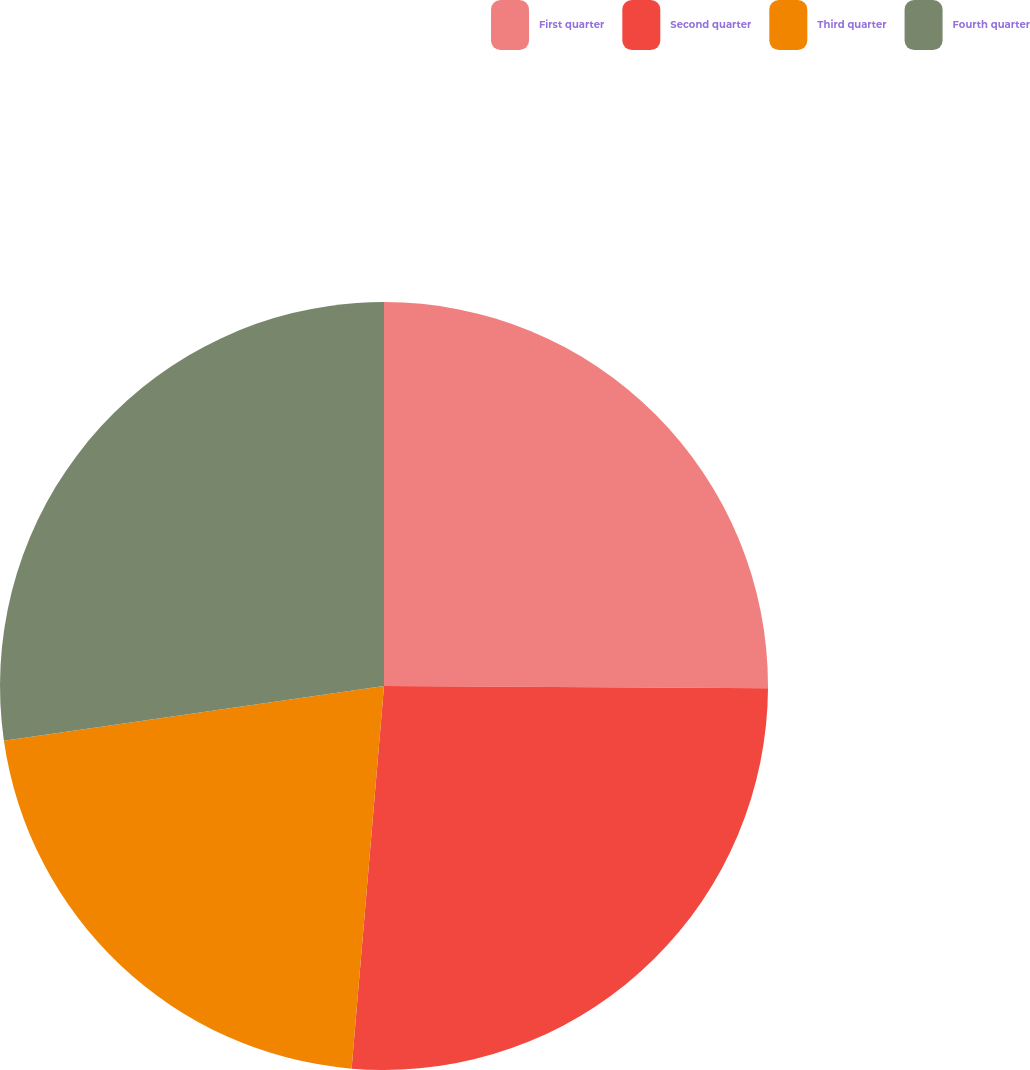Convert chart to OTSL. <chart><loc_0><loc_0><loc_500><loc_500><pie_chart><fcel>First quarter<fcel>Second quarter<fcel>Third quarter<fcel>Fourth quarter<nl><fcel>25.09%<fcel>26.25%<fcel>21.38%<fcel>27.27%<nl></chart> 